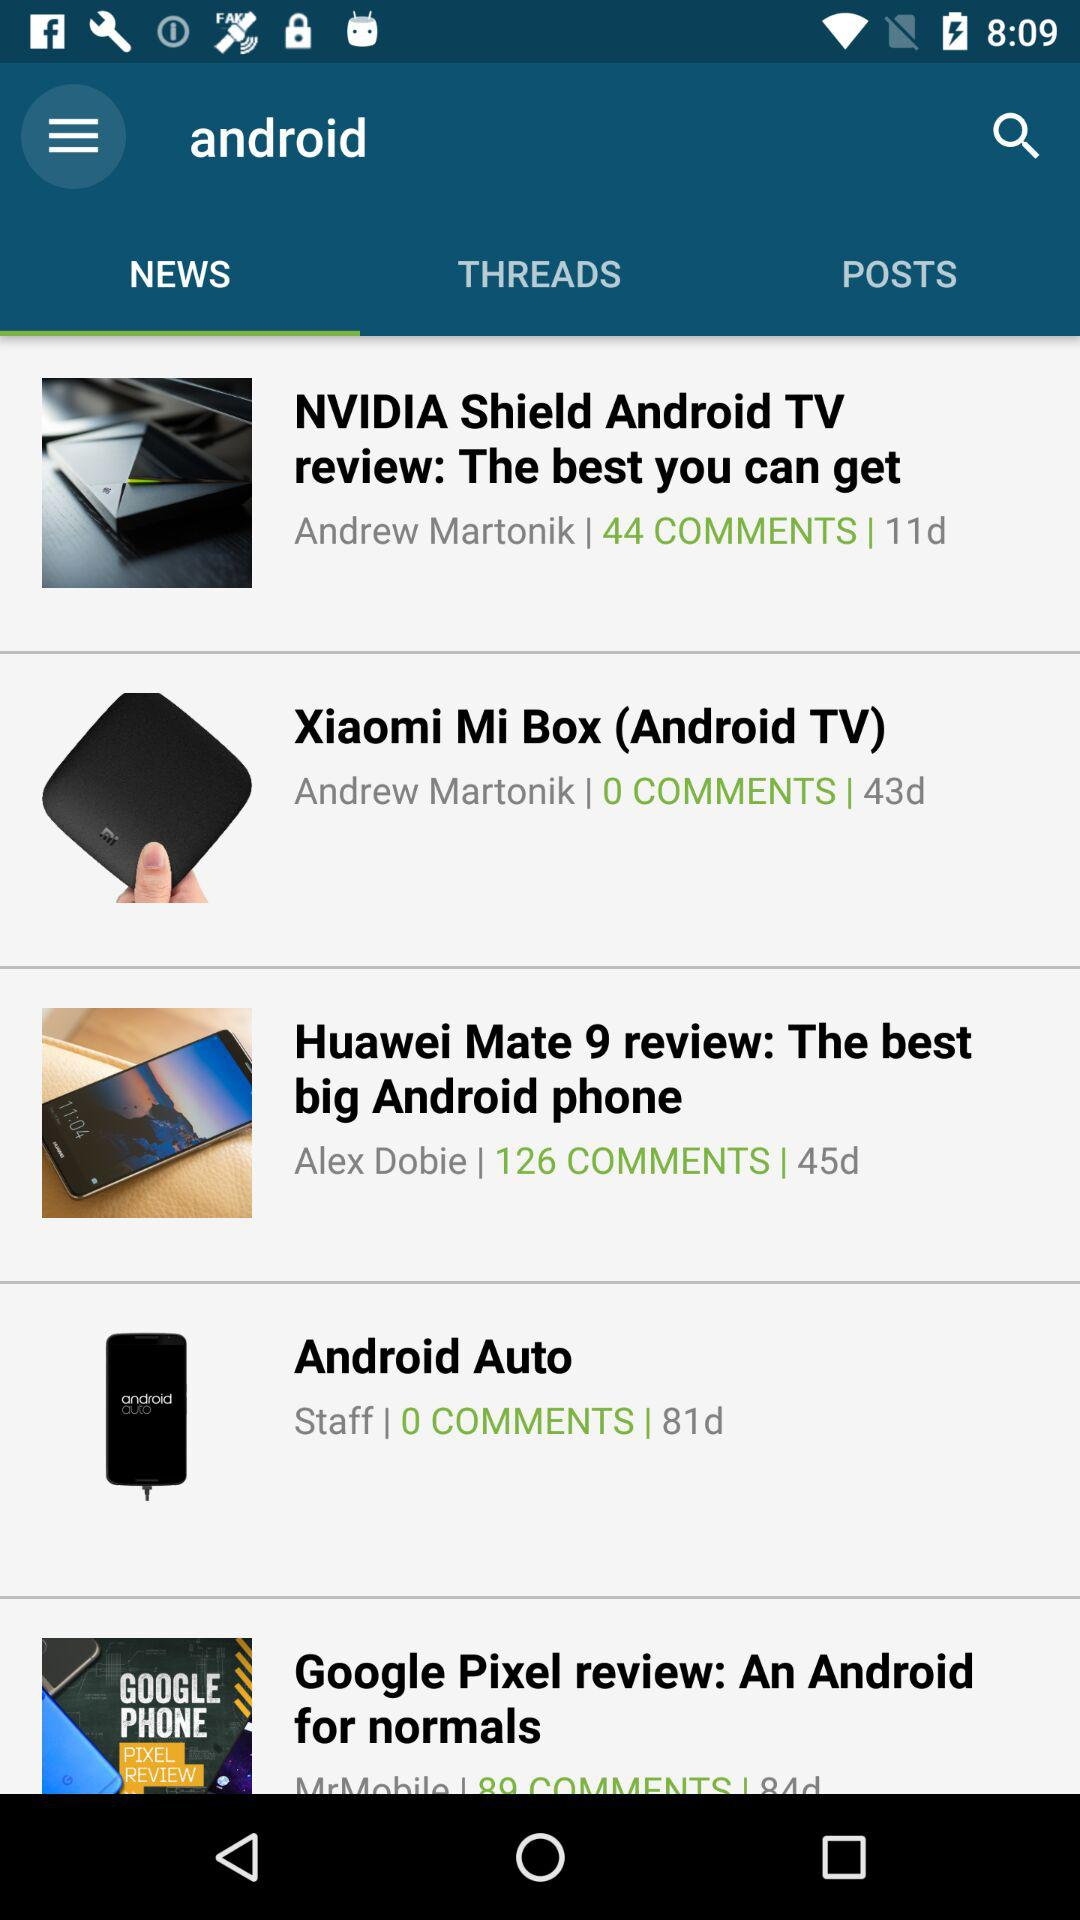How many comments are available in "The best you can get"? The available comments in "The best you can get" are 44. 